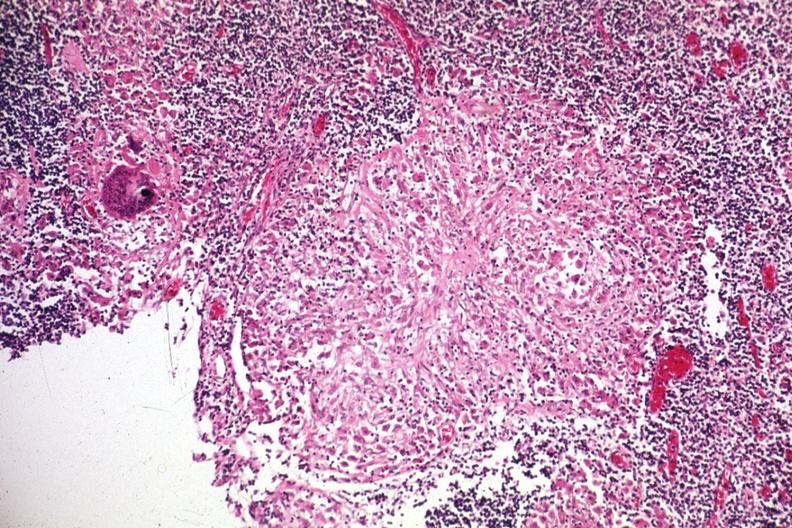s rocky mountain present?
Answer the question using a single word or phrase. No 